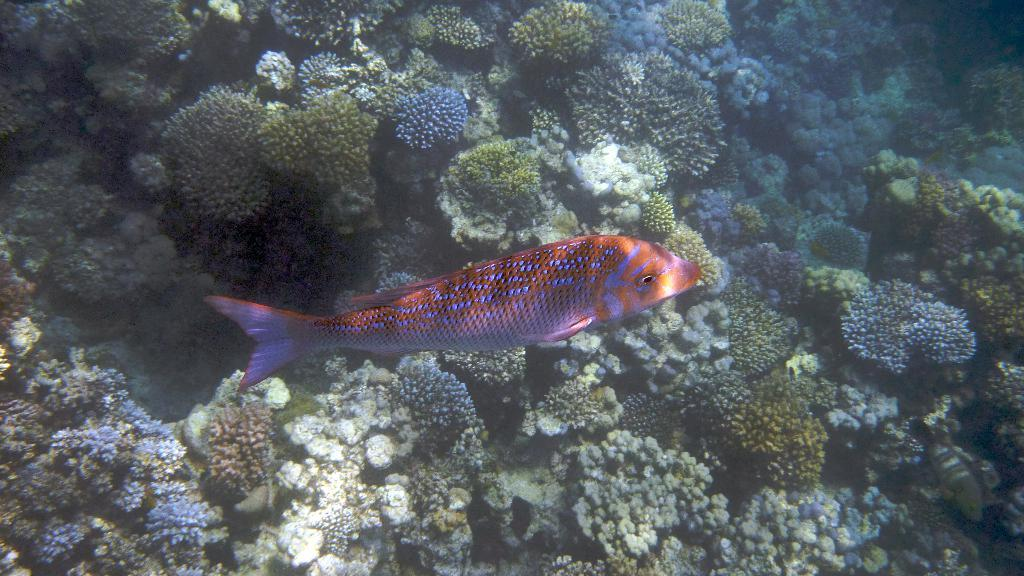What is the main subject in the center of the image? There is a fish in the center of the image. What can be seen in the background of the image? There are water plants in the background of the image. What type of alarm can be heard going off in the image? There is no alarm present in the image; it is a picture of a fish and water plants. How does the pig interact with the fish in the image? There is no pig present in the image; it only features a fish and water plants. 